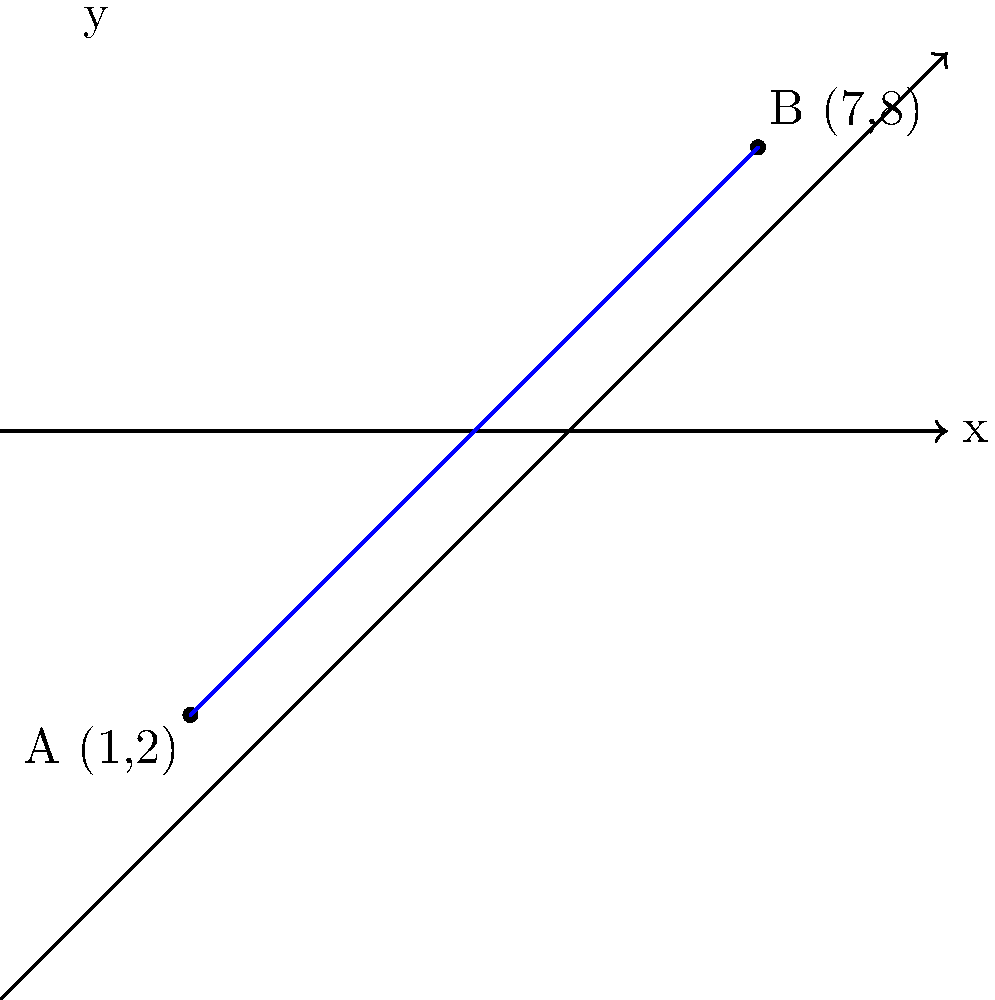Two community centers are located on a coordinate plane representing a city map. Center A is at (1,2) and Center B is at (7,8). Calculate the distance between these two centers to assess if resources are equitably distributed across the community. Round your answer to two decimal places. To calculate the distance between two points on a coordinate plane, we can use the distance formula, which is derived from the Pythagorean theorem:

$$d = \sqrt{(x_2 - x_1)^2 + (y_2 - y_1)^2}$$

Where $(x_1, y_1)$ are the coordinates of the first point and $(x_2, y_2)$ are the coordinates of the second point.

Step 1: Identify the coordinates
- Center A: $(x_1, y_1) = (1, 2)$
- Center B: $(x_2, y_2) = (7, 8)$

Step 2: Plug the coordinates into the distance formula
$$d = \sqrt{(7 - 1)^2 + (8 - 2)^2}$$

Step 3: Simplify the expressions inside the parentheses
$$d = \sqrt{6^2 + 6^2}$$

Step 4: Calculate the squares
$$d = \sqrt{36 + 36}$$

Step 5: Add the numbers under the square root
$$d = \sqrt{72}$$

Step 6: Simplify the square root
$$d = 6\sqrt{2}$$

Step 7: Use a calculator to get the decimal approximation and round to two decimal places
$$d \approx 8.49$$

Therefore, the distance between the two community centers is approximately 8.49 units.
Answer: 8.49 units 